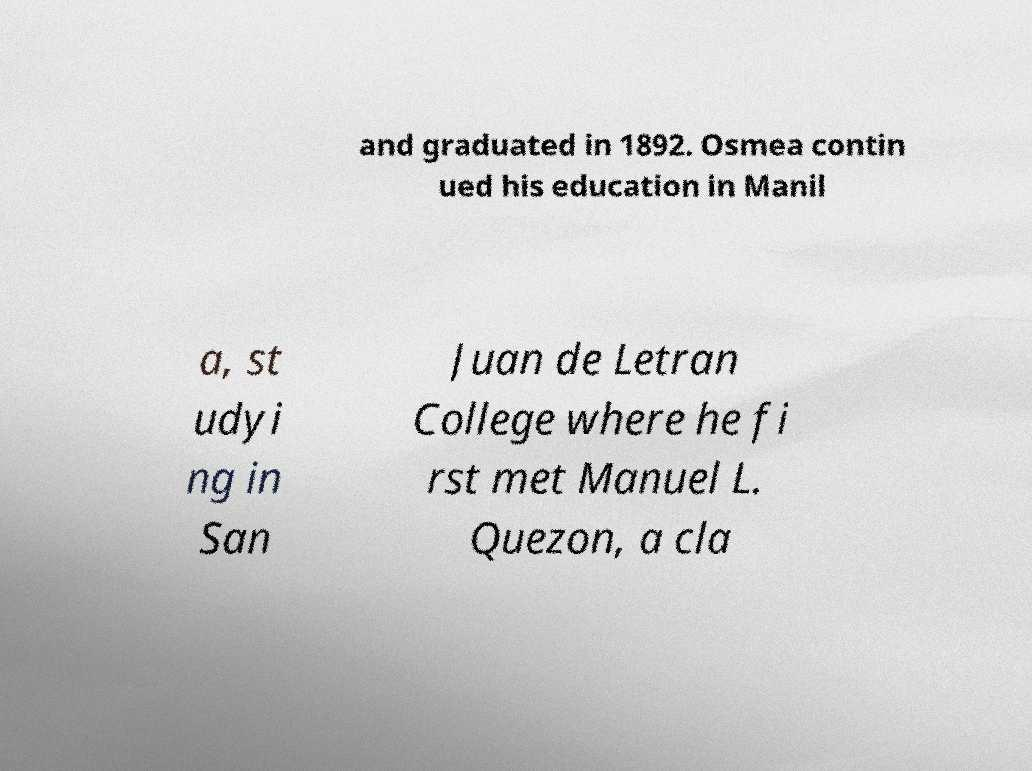Can you accurately transcribe the text from the provided image for me? and graduated in 1892. Osmea contin ued his education in Manil a, st udyi ng in San Juan de Letran College where he fi rst met Manuel L. Quezon, a cla 